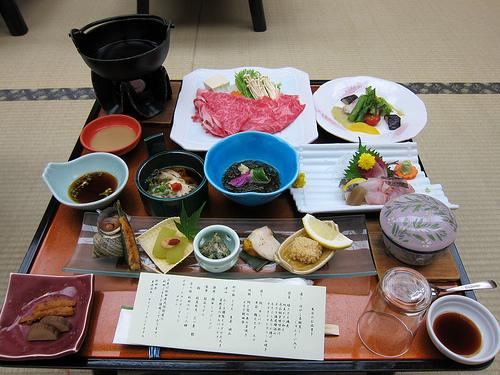Describe the variety of food and drinks being served. Asian dishes including sushi, caviar, and sliced meat are served alongside soup, soy sauce, and lemon, with an overturned glass waiting to be used. Discuss the type of cuisine and tableware showcased. A variety of Asian delicacies are present on the table, served on an array of plates and bowls, with utensils such as chopsticks and spoons nearby. Mention a few intriguing details about the image. There's an upturned glass, a small yellow flower for decoration, a printed restaurant bill, and a set of chopsticks atop the array of Asian dishes. Provide a summary of the main elements in the image. The image showcases a table setting with an assortment of Japanese dishes, bowls of sauce, a clear glass, utensils, and a bill for the meal. Describe the table and the dining environment briefly. A table set with various Japanese dishes on plates and bowls, along with appropriate utensils, and a menu bill, creating a cozy dining atmosphere. Provide a brief overview of the arrangements on the table. The table features a spread of Japanese food on plates and bowls, accompanied by utensils like spoons and chopsticks, and a white restaurant bill. Focus on the different types of dishes and their presentation. The table includes beautifully presented sushi, caviar, sliced meat, vegetables, and sauce in colorful bowls and plates, alongside utensils and a bill. Mention a few items of interest found in the image. There are sushi on a fluted plate, a blue bowl of caviar, a small yellow flower for decoration, and an upturned glass on the table. List a few colors and items present in the image. Blue bowl of caviar, orange bowl of sauce, yellow lemon slice, green decorative leaf, clear upturned glass, and white bill on the table. Describe the table setting in a concise manner. The table has various Asian delicacies, utensils, soy sauce, soup, and a bill for the meal on a tray with chopsticks on top. 